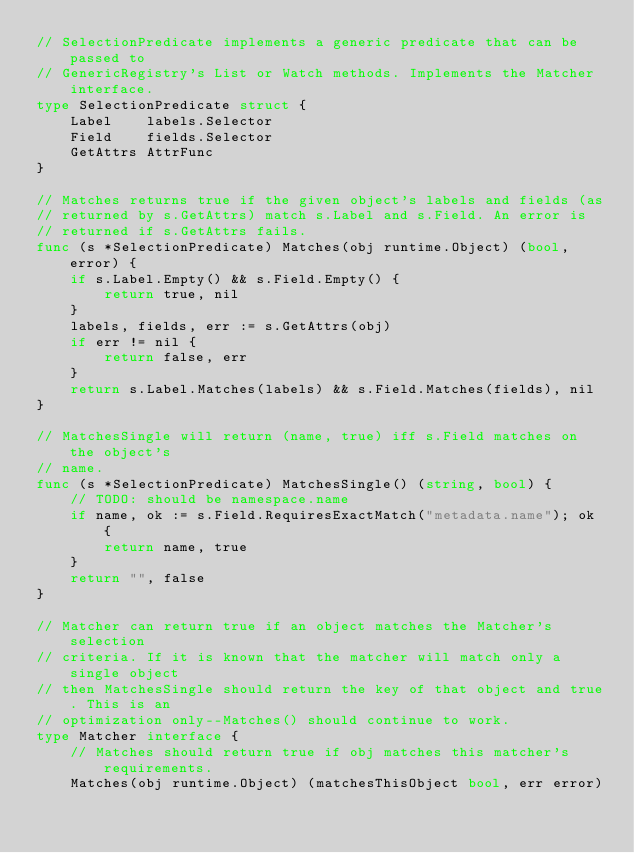Convert code to text. <code><loc_0><loc_0><loc_500><loc_500><_Go_>// SelectionPredicate implements a generic predicate that can be passed to
// GenericRegistry's List or Watch methods. Implements the Matcher interface.
type SelectionPredicate struct {
	Label    labels.Selector
	Field    fields.Selector
	GetAttrs AttrFunc
}

// Matches returns true if the given object's labels and fields (as
// returned by s.GetAttrs) match s.Label and s.Field. An error is
// returned if s.GetAttrs fails.
func (s *SelectionPredicate) Matches(obj runtime.Object) (bool, error) {
	if s.Label.Empty() && s.Field.Empty() {
		return true, nil
	}
	labels, fields, err := s.GetAttrs(obj)
	if err != nil {
		return false, err
	}
	return s.Label.Matches(labels) && s.Field.Matches(fields), nil
}

// MatchesSingle will return (name, true) iff s.Field matches on the object's
// name.
func (s *SelectionPredicate) MatchesSingle() (string, bool) {
	// TODO: should be namespace.name
	if name, ok := s.Field.RequiresExactMatch("metadata.name"); ok {
		return name, true
	}
	return "", false
}

// Matcher can return true if an object matches the Matcher's selection
// criteria. If it is known that the matcher will match only a single object
// then MatchesSingle should return the key of that object and true. This is an
// optimization only--Matches() should continue to work.
type Matcher interface {
	// Matches should return true if obj matches this matcher's requirements.
	Matches(obj runtime.Object) (matchesThisObject bool, err error)
</code> 